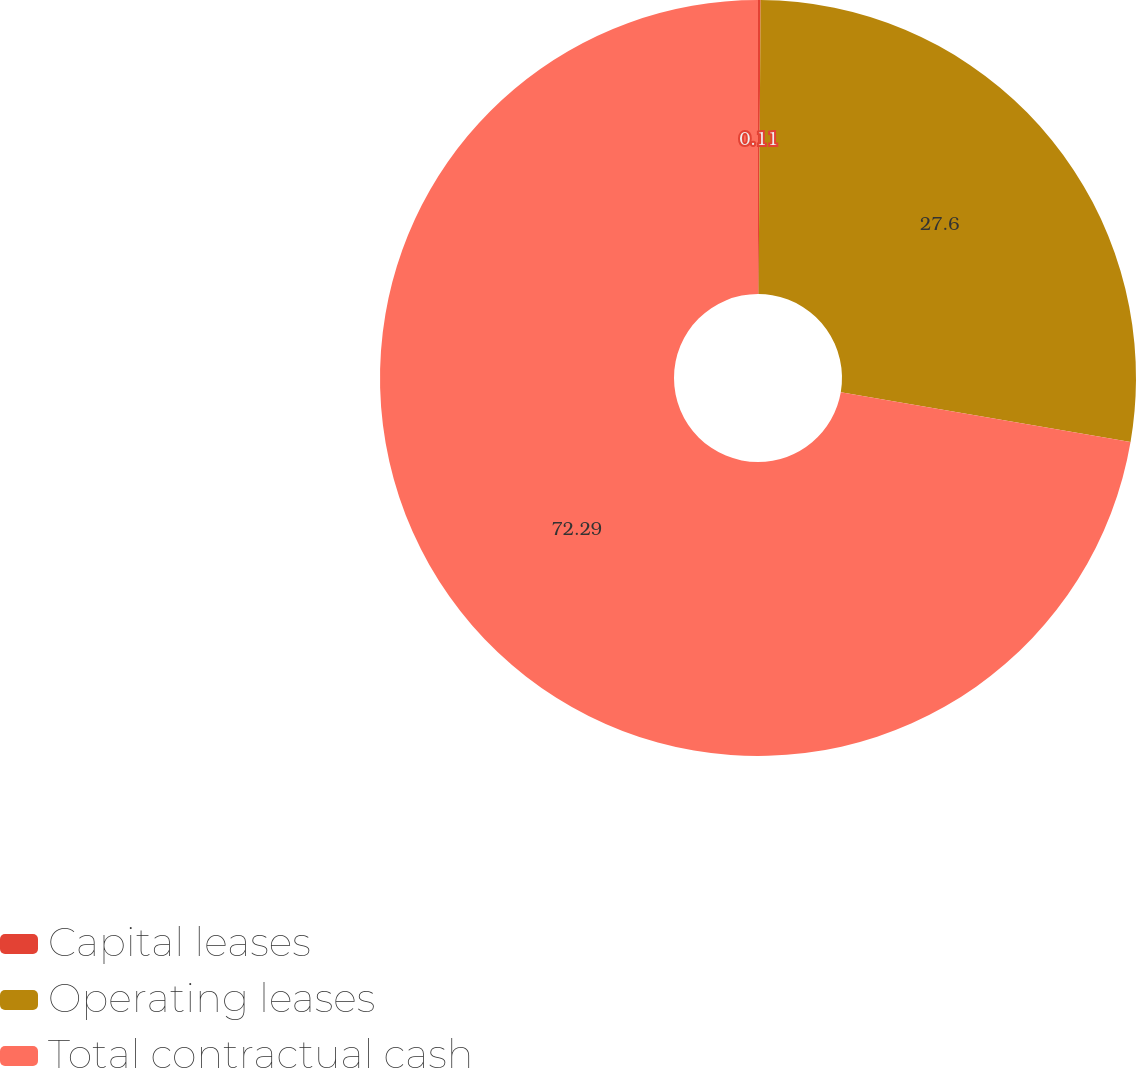Convert chart to OTSL. <chart><loc_0><loc_0><loc_500><loc_500><pie_chart><fcel>Capital leases<fcel>Operating leases<fcel>Total contractual cash<nl><fcel>0.11%<fcel>27.6%<fcel>72.3%<nl></chart> 